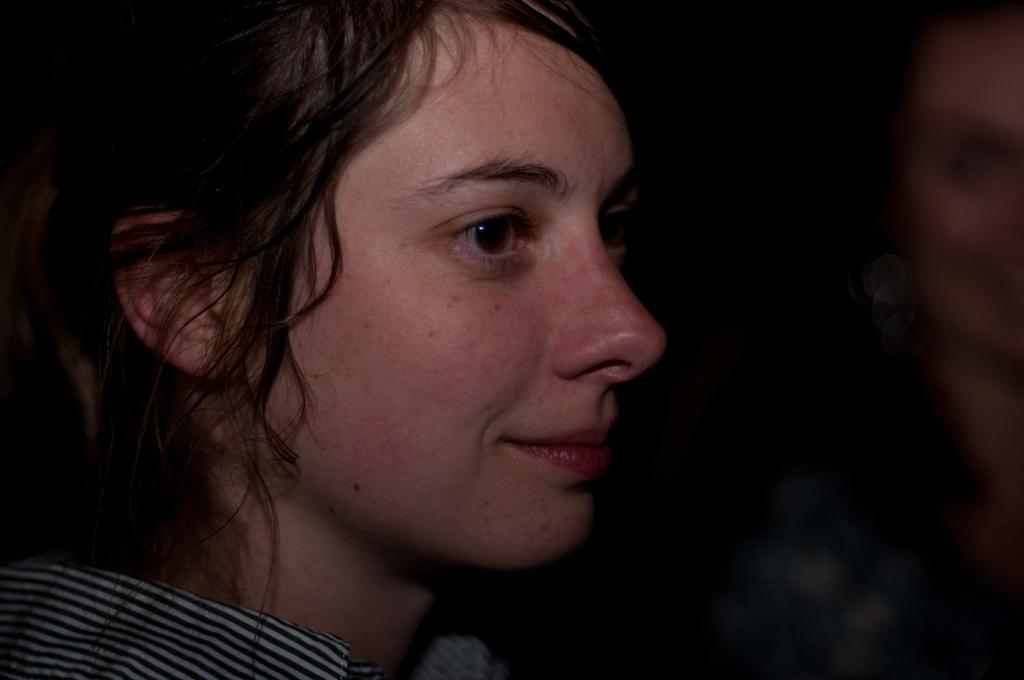Who is present in the image? There is a woman in the image. What is the woman doing in the image? The woman is smiling in the image. What is the woman wearing in the image? The woman is wearing clothes in the image. Who else is present in the image? There is another person beside the woman in the image. How would you describe the background of the image? The background of the image is blurred. What type of grass can be seen growing in the image? There is no grass present in the image. How many letters are visible in the image? There are no letters visible in the image. 